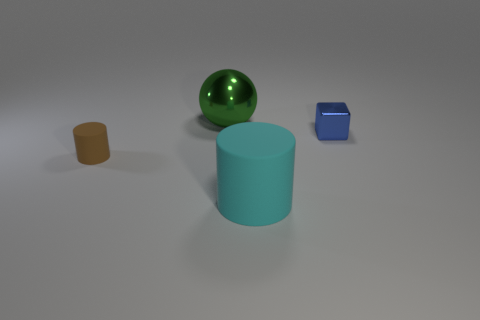What number of tiny objects are either blue metal objects or purple things?
Ensure brevity in your answer.  1. There is a small matte thing; how many large green metal things are in front of it?
Ensure brevity in your answer.  0. There is a shiny thing that is the same size as the brown matte cylinder; what is its shape?
Your response must be concise. Cube. How many brown objects are rubber cylinders or small cylinders?
Offer a terse response. 1. What number of brown things are the same size as the metal block?
Give a very brief answer. 1. What number of objects are large cyan rubber things or matte things to the right of the large metal thing?
Offer a terse response. 1. Do the metal object behind the small metal block and the matte object that is right of the large metallic object have the same size?
Make the answer very short. Yes. What number of other tiny objects are the same shape as the small brown rubber thing?
Make the answer very short. 0. There is another small object that is the same material as the cyan object; what shape is it?
Your answer should be compact. Cylinder. There is a small thing that is in front of the metal object that is in front of the thing behind the blue shiny thing; what is its material?
Your response must be concise. Rubber. 